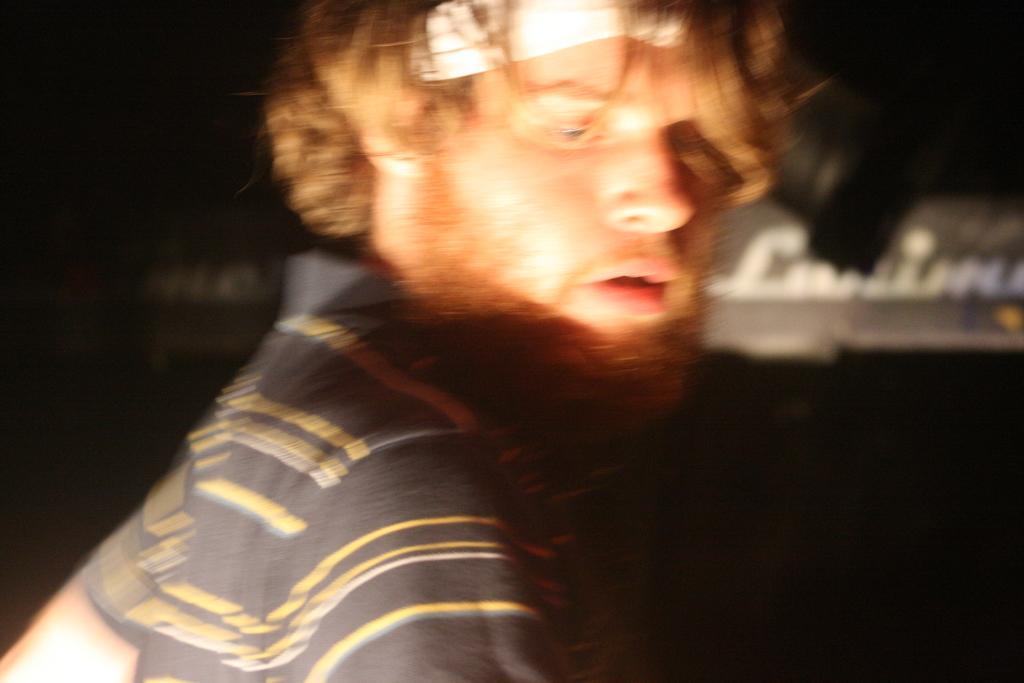Could you give a brief overview of what you see in this image? In this image we can see one person and there is some text board on the right side of this image, and it is dark in the background. 